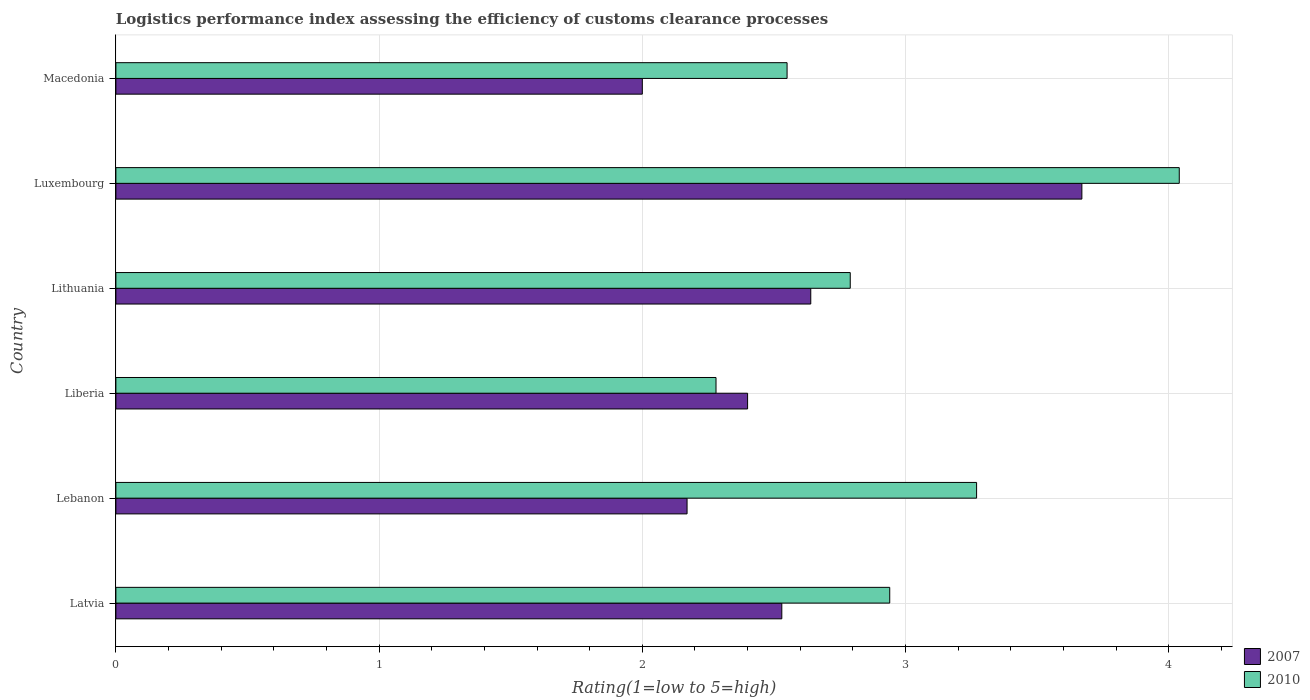How many different coloured bars are there?
Provide a short and direct response. 2. How many groups of bars are there?
Make the answer very short. 6. How many bars are there on the 3rd tick from the top?
Offer a very short reply. 2. What is the label of the 6th group of bars from the top?
Provide a succinct answer. Latvia. What is the Logistic performance index in 2010 in Lithuania?
Make the answer very short. 2.79. Across all countries, what is the maximum Logistic performance index in 2010?
Make the answer very short. 4.04. Across all countries, what is the minimum Logistic performance index in 2007?
Offer a very short reply. 2. In which country was the Logistic performance index in 2007 maximum?
Your answer should be very brief. Luxembourg. In which country was the Logistic performance index in 2007 minimum?
Your answer should be compact. Macedonia. What is the total Logistic performance index in 2010 in the graph?
Offer a terse response. 17.87. What is the difference between the Logistic performance index in 2010 in Latvia and that in Macedonia?
Offer a terse response. 0.39. What is the difference between the Logistic performance index in 2010 in Lebanon and the Logistic performance index in 2007 in Latvia?
Offer a terse response. 0.74. What is the average Logistic performance index in 2007 per country?
Your answer should be very brief. 2.57. What is the difference between the Logistic performance index in 2007 and Logistic performance index in 2010 in Luxembourg?
Your response must be concise. -0.37. In how many countries, is the Logistic performance index in 2010 greater than 3 ?
Offer a very short reply. 2. What is the ratio of the Logistic performance index in 2010 in Liberia to that in Luxembourg?
Provide a succinct answer. 0.56. Is the Logistic performance index in 2007 in Latvia less than that in Macedonia?
Give a very brief answer. No. Is the difference between the Logistic performance index in 2007 in Lebanon and Lithuania greater than the difference between the Logistic performance index in 2010 in Lebanon and Lithuania?
Give a very brief answer. No. What is the difference between the highest and the second highest Logistic performance index in 2010?
Your answer should be compact. 0.77. What is the difference between the highest and the lowest Logistic performance index in 2007?
Offer a terse response. 1.67. In how many countries, is the Logistic performance index in 2007 greater than the average Logistic performance index in 2007 taken over all countries?
Give a very brief answer. 2. Is the sum of the Logistic performance index in 2010 in Lebanon and Liberia greater than the maximum Logistic performance index in 2007 across all countries?
Your response must be concise. Yes. What does the 2nd bar from the top in Liberia represents?
Your response must be concise. 2007. What does the 1st bar from the bottom in Latvia represents?
Make the answer very short. 2007. Are all the bars in the graph horizontal?
Your answer should be very brief. Yes. What is the difference between two consecutive major ticks on the X-axis?
Make the answer very short. 1. How many legend labels are there?
Provide a succinct answer. 2. How are the legend labels stacked?
Keep it short and to the point. Vertical. What is the title of the graph?
Offer a terse response. Logistics performance index assessing the efficiency of customs clearance processes. What is the label or title of the X-axis?
Provide a short and direct response. Rating(1=low to 5=high). What is the Rating(1=low to 5=high) in 2007 in Latvia?
Your answer should be compact. 2.53. What is the Rating(1=low to 5=high) of 2010 in Latvia?
Your answer should be very brief. 2.94. What is the Rating(1=low to 5=high) in 2007 in Lebanon?
Keep it short and to the point. 2.17. What is the Rating(1=low to 5=high) in 2010 in Lebanon?
Offer a very short reply. 3.27. What is the Rating(1=low to 5=high) of 2007 in Liberia?
Keep it short and to the point. 2.4. What is the Rating(1=low to 5=high) of 2010 in Liberia?
Give a very brief answer. 2.28. What is the Rating(1=low to 5=high) in 2007 in Lithuania?
Your response must be concise. 2.64. What is the Rating(1=low to 5=high) of 2010 in Lithuania?
Your answer should be compact. 2.79. What is the Rating(1=low to 5=high) of 2007 in Luxembourg?
Provide a short and direct response. 3.67. What is the Rating(1=low to 5=high) of 2010 in Luxembourg?
Offer a very short reply. 4.04. What is the Rating(1=low to 5=high) of 2010 in Macedonia?
Your answer should be very brief. 2.55. Across all countries, what is the maximum Rating(1=low to 5=high) of 2007?
Provide a succinct answer. 3.67. Across all countries, what is the maximum Rating(1=low to 5=high) of 2010?
Your answer should be compact. 4.04. Across all countries, what is the minimum Rating(1=low to 5=high) of 2010?
Your answer should be compact. 2.28. What is the total Rating(1=low to 5=high) of 2007 in the graph?
Your answer should be compact. 15.41. What is the total Rating(1=low to 5=high) in 2010 in the graph?
Make the answer very short. 17.87. What is the difference between the Rating(1=low to 5=high) in 2007 in Latvia and that in Lebanon?
Offer a very short reply. 0.36. What is the difference between the Rating(1=low to 5=high) in 2010 in Latvia and that in Lebanon?
Provide a short and direct response. -0.33. What is the difference between the Rating(1=low to 5=high) of 2007 in Latvia and that in Liberia?
Provide a short and direct response. 0.13. What is the difference between the Rating(1=low to 5=high) of 2010 in Latvia and that in Liberia?
Your answer should be very brief. 0.66. What is the difference between the Rating(1=low to 5=high) in 2007 in Latvia and that in Lithuania?
Your response must be concise. -0.11. What is the difference between the Rating(1=low to 5=high) in 2010 in Latvia and that in Lithuania?
Your answer should be compact. 0.15. What is the difference between the Rating(1=low to 5=high) of 2007 in Latvia and that in Luxembourg?
Ensure brevity in your answer.  -1.14. What is the difference between the Rating(1=low to 5=high) of 2007 in Latvia and that in Macedonia?
Give a very brief answer. 0.53. What is the difference between the Rating(1=low to 5=high) in 2010 in Latvia and that in Macedonia?
Your answer should be compact. 0.39. What is the difference between the Rating(1=low to 5=high) in 2007 in Lebanon and that in Liberia?
Offer a terse response. -0.23. What is the difference between the Rating(1=low to 5=high) in 2010 in Lebanon and that in Liberia?
Your answer should be compact. 0.99. What is the difference between the Rating(1=low to 5=high) in 2007 in Lebanon and that in Lithuania?
Your answer should be compact. -0.47. What is the difference between the Rating(1=low to 5=high) in 2010 in Lebanon and that in Lithuania?
Keep it short and to the point. 0.48. What is the difference between the Rating(1=low to 5=high) of 2010 in Lebanon and that in Luxembourg?
Your answer should be compact. -0.77. What is the difference between the Rating(1=low to 5=high) of 2007 in Lebanon and that in Macedonia?
Offer a terse response. 0.17. What is the difference between the Rating(1=low to 5=high) in 2010 in Lebanon and that in Macedonia?
Provide a succinct answer. 0.72. What is the difference between the Rating(1=low to 5=high) of 2007 in Liberia and that in Lithuania?
Your response must be concise. -0.24. What is the difference between the Rating(1=low to 5=high) in 2010 in Liberia and that in Lithuania?
Offer a terse response. -0.51. What is the difference between the Rating(1=low to 5=high) in 2007 in Liberia and that in Luxembourg?
Give a very brief answer. -1.27. What is the difference between the Rating(1=low to 5=high) in 2010 in Liberia and that in Luxembourg?
Offer a terse response. -1.76. What is the difference between the Rating(1=low to 5=high) of 2007 in Liberia and that in Macedonia?
Keep it short and to the point. 0.4. What is the difference between the Rating(1=low to 5=high) of 2010 in Liberia and that in Macedonia?
Keep it short and to the point. -0.27. What is the difference between the Rating(1=low to 5=high) of 2007 in Lithuania and that in Luxembourg?
Offer a terse response. -1.03. What is the difference between the Rating(1=low to 5=high) in 2010 in Lithuania and that in Luxembourg?
Make the answer very short. -1.25. What is the difference between the Rating(1=low to 5=high) of 2007 in Lithuania and that in Macedonia?
Keep it short and to the point. 0.64. What is the difference between the Rating(1=low to 5=high) of 2010 in Lithuania and that in Macedonia?
Your response must be concise. 0.24. What is the difference between the Rating(1=low to 5=high) in 2007 in Luxembourg and that in Macedonia?
Make the answer very short. 1.67. What is the difference between the Rating(1=low to 5=high) in 2010 in Luxembourg and that in Macedonia?
Offer a terse response. 1.49. What is the difference between the Rating(1=low to 5=high) of 2007 in Latvia and the Rating(1=low to 5=high) of 2010 in Lebanon?
Your answer should be very brief. -0.74. What is the difference between the Rating(1=low to 5=high) in 2007 in Latvia and the Rating(1=low to 5=high) in 2010 in Liberia?
Give a very brief answer. 0.25. What is the difference between the Rating(1=low to 5=high) in 2007 in Latvia and the Rating(1=low to 5=high) in 2010 in Lithuania?
Your answer should be very brief. -0.26. What is the difference between the Rating(1=low to 5=high) in 2007 in Latvia and the Rating(1=low to 5=high) in 2010 in Luxembourg?
Provide a short and direct response. -1.51. What is the difference between the Rating(1=low to 5=high) in 2007 in Latvia and the Rating(1=low to 5=high) in 2010 in Macedonia?
Your response must be concise. -0.02. What is the difference between the Rating(1=low to 5=high) in 2007 in Lebanon and the Rating(1=low to 5=high) in 2010 in Liberia?
Provide a short and direct response. -0.11. What is the difference between the Rating(1=low to 5=high) in 2007 in Lebanon and the Rating(1=low to 5=high) in 2010 in Lithuania?
Offer a very short reply. -0.62. What is the difference between the Rating(1=low to 5=high) of 2007 in Lebanon and the Rating(1=low to 5=high) of 2010 in Luxembourg?
Ensure brevity in your answer.  -1.87. What is the difference between the Rating(1=low to 5=high) in 2007 in Lebanon and the Rating(1=low to 5=high) in 2010 in Macedonia?
Offer a very short reply. -0.38. What is the difference between the Rating(1=low to 5=high) of 2007 in Liberia and the Rating(1=low to 5=high) of 2010 in Lithuania?
Keep it short and to the point. -0.39. What is the difference between the Rating(1=low to 5=high) of 2007 in Liberia and the Rating(1=low to 5=high) of 2010 in Luxembourg?
Your answer should be very brief. -1.64. What is the difference between the Rating(1=low to 5=high) of 2007 in Liberia and the Rating(1=low to 5=high) of 2010 in Macedonia?
Give a very brief answer. -0.15. What is the difference between the Rating(1=low to 5=high) in 2007 in Lithuania and the Rating(1=low to 5=high) in 2010 in Macedonia?
Your answer should be compact. 0.09. What is the difference between the Rating(1=low to 5=high) of 2007 in Luxembourg and the Rating(1=low to 5=high) of 2010 in Macedonia?
Give a very brief answer. 1.12. What is the average Rating(1=low to 5=high) of 2007 per country?
Provide a succinct answer. 2.57. What is the average Rating(1=low to 5=high) in 2010 per country?
Provide a short and direct response. 2.98. What is the difference between the Rating(1=low to 5=high) of 2007 and Rating(1=low to 5=high) of 2010 in Latvia?
Provide a succinct answer. -0.41. What is the difference between the Rating(1=low to 5=high) in 2007 and Rating(1=low to 5=high) in 2010 in Liberia?
Offer a very short reply. 0.12. What is the difference between the Rating(1=low to 5=high) in 2007 and Rating(1=low to 5=high) in 2010 in Luxembourg?
Your response must be concise. -0.37. What is the difference between the Rating(1=low to 5=high) in 2007 and Rating(1=low to 5=high) in 2010 in Macedonia?
Provide a succinct answer. -0.55. What is the ratio of the Rating(1=low to 5=high) of 2007 in Latvia to that in Lebanon?
Your response must be concise. 1.17. What is the ratio of the Rating(1=low to 5=high) of 2010 in Latvia to that in Lebanon?
Provide a short and direct response. 0.9. What is the ratio of the Rating(1=low to 5=high) of 2007 in Latvia to that in Liberia?
Offer a terse response. 1.05. What is the ratio of the Rating(1=low to 5=high) in 2010 in Latvia to that in Liberia?
Keep it short and to the point. 1.29. What is the ratio of the Rating(1=low to 5=high) of 2007 in Latvia to that in Lithuania?
Your answer should be very brief. 0.96. What is the ratio of the Rating(1=low to 5=high) in 2010 in Latvia to that in Lithuania?
Provide a succinct answer. 1.05. What is the ratio of the Rating(1=low to 5=high) in 2007 in Latvia to that in Luxembourg?
Give a very brief answer. 0.69. What is the ratio of the Rating(1=low to 5=high) of 2010 in Latvia to that in Luxembourg?
Offer a very short reply. 0.73. What is the ratio of the Rating(1=low to 5=high) of 2007 in Latvia to that in Macedonia?
Your answer should be compact. 1.26. What is the ratio of the Rating(1=low to 5=high) in 2010 in Latvia to that in Macedonia?
Keep it short and to the point. 1.15. What is the ratio of the Rating(1=low to 5=high) of 2007 in Lebanon to that in Liberia?
Provide a succinct answer. 0.9. What is the ratio of the Rating(1=low to 5=high) in 2010 in Lebanon to that in Liberia?
Offer a terse response. 1.43. What is the ratio of the Rating(1=low to 5=high) in 2007 in Lebanon to that in Lithuania?
Ensure brevity in your answer.  0.82. What is the ratio of the Rating(1=low to 5=high) in 2010 in Lebanon to that in Lithuania?
Offer a very short reply. 1.17. What is the ratio of the Rating(1=low to 5=high) of 2007 in Lebanon to that in Luxembourg?
Ensure brevity in your answer.  0.59. What is the ratio of the Rating(1=low to 5=high) in 2010 in Lebanon to that in Luxembourg?
Offer a terse response. 0.81. What is the ratio of the Rating(1=low to 5=high) in 2007 in Lebanon to that in Macedonia?
Your answer should be compact. 1.08. What is the ratio of the Rating(1=low to 5=high) of 2010 in Lebanon to that in Macedonia?
Your answer should be very brief. 1.28. What is the ratio of the Rating(1=low to 5=high) of 2007 in Liberia to that in Lithuania?
Make the answer very short. 0.91. What is the ratio of the Rating(1=low to 5=high) of 2010 in Liberia to that in Lithuania?
Keep it short and to the point. 0.82. What is the ratio of the Rating(1=low to 5=high) in 2007 in Liberia to that in Luxembourg?
Provide a succinct answer. 0.65. What is the ratio of the Rating(1=low to 5=high) in 2010 in Liberia to that in Luxembourg?
Make the answer very short. 0.56. What is the ratio of the Rating(1=low to 5=high) of 2010 in Liberia to that in Macedonia?
Provide a short and direct response. 0.89. What is the ratio of the Rating(1=low to 5=high) of 2007 in Lithuania to that in Luxembourg?
Offer a very short reply. 0.72. What is the ratio of the Rating(1=low to 5=high) in 2010 in Lithuania to that in Luxembourg?
Keep it short and to the point. 0.69. What is the ratio of the Rating(1=low to 5=high) in 2007 in Lithuania to that in Macedonia?
Offer a terse response. 1.32. What is the ratio of the Rating(1=low to 5=high) in 2010 in Lithuania to that in Macedonia?
Keep it short and to the point. 1.09. What is the ratio of the Rating(1=low to 5=high) in 2007 in Luxembourg to that in Macedonia?
Offer a very short reply. 1.83. What is the ratio of the Rating(1=low to 5=high) in 2010 in Luxembourg to that in Macedonia?
Make the answer very short. 1.58. What is the difference between the highest and the second highest Rating(1=low to 5=high) of 2007?
Your answer should be very brief. 1.03. What is the difference between the highest and the second highest Rating(1=low to 5=high) of 2010?
Your answer should be compact. 0.77. What is the difference between the highest and the lowest Rating(1=low to 5=high) in 2007?
Offer a terse response. 1.67. What is the difference between the highest and the lowest Rating(1=low to 5=high) in 2010?
Your answer should be very brief. 1.76. 